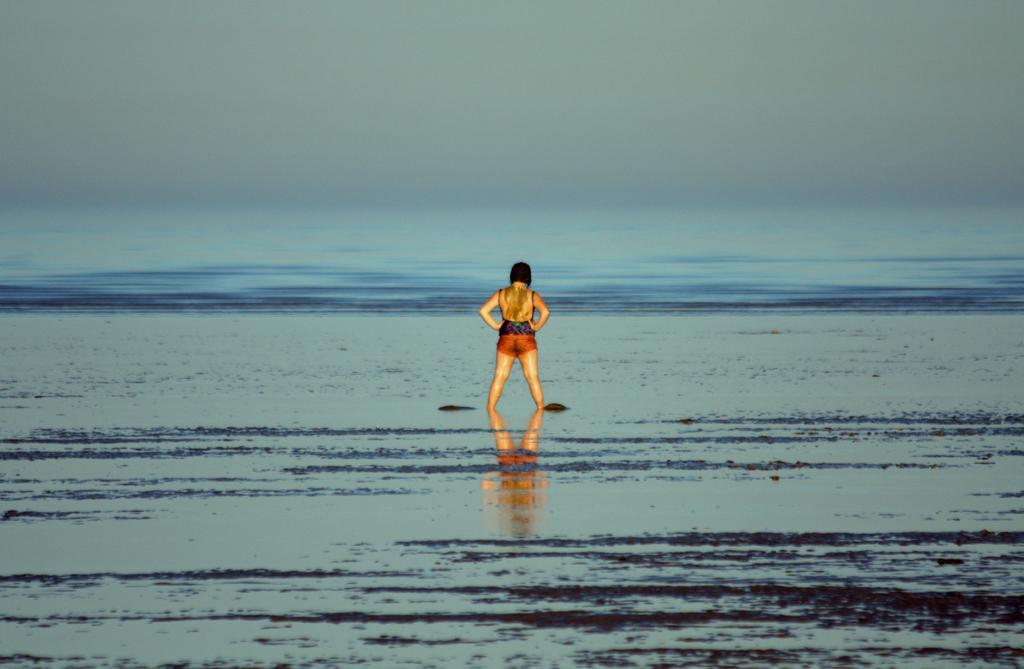What is the woman doing in the image? The woman is standing in the water. What type of water is the woman standing in? The water appears to be an ocean. What can be seen above the water in the image? The sky is visible above the water. What is present in the sky in the image? Clouds are present in the sky. What type of plough is being used by the woman in the image? There is no plough present in the image; the woman is standing in the water. What religious symbols can be seen in the image? There are no religious symbols present in the image; it features a woman standing in the water with a visible sky and clouds. 